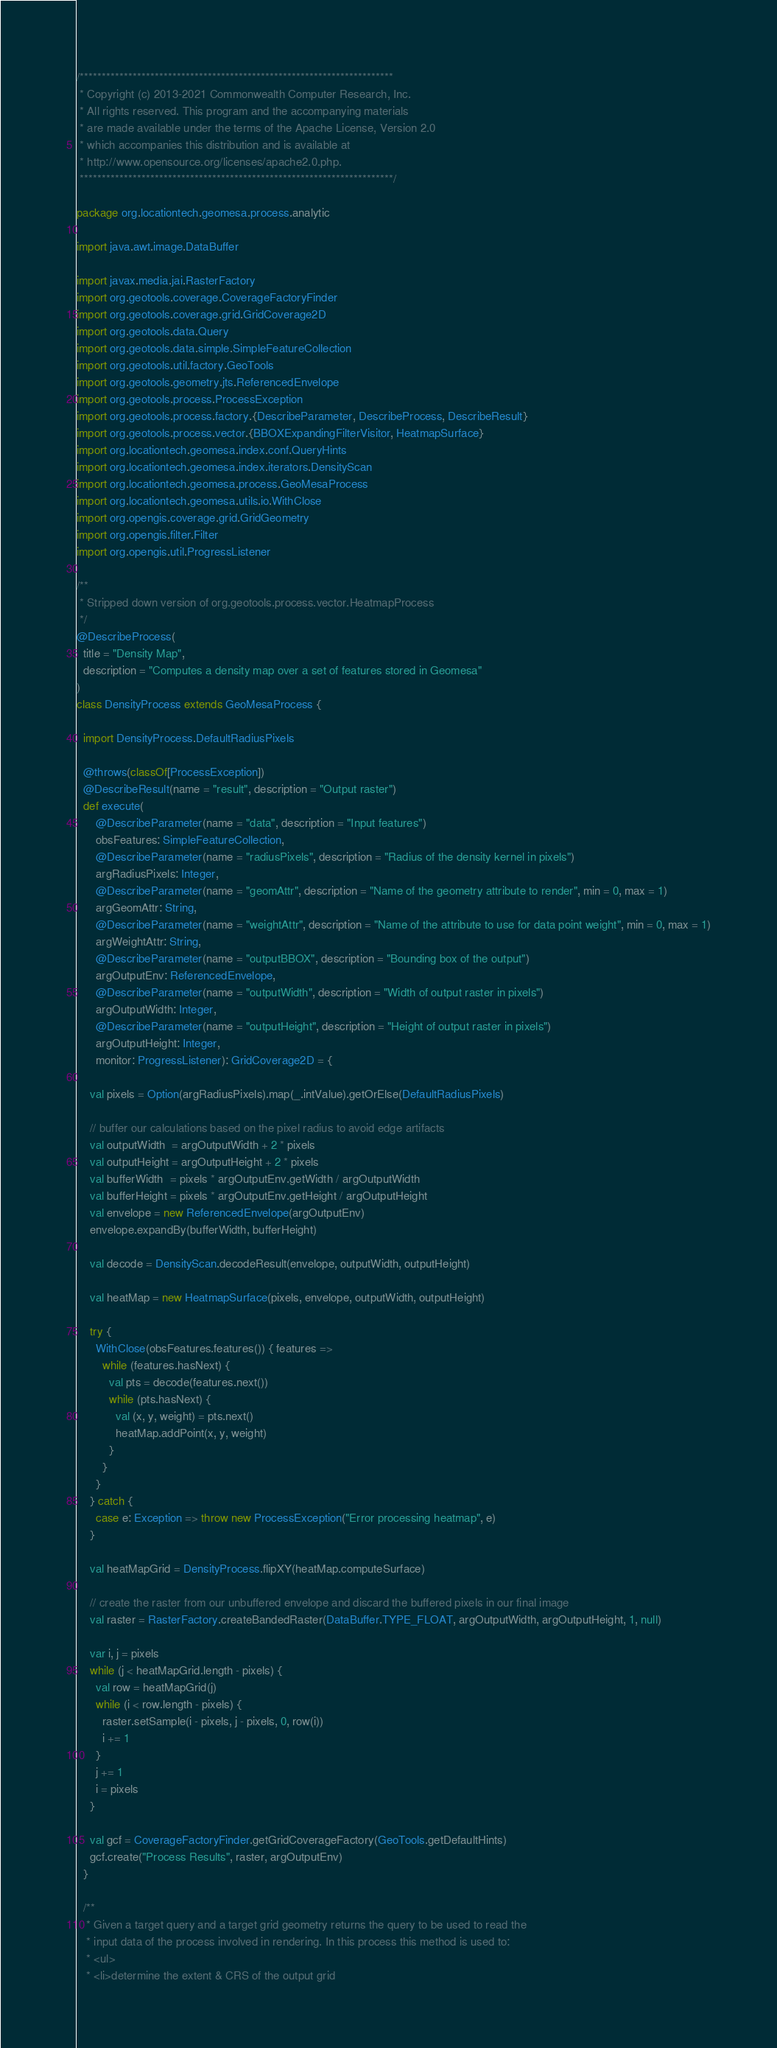<code> <loc_0><loc_0><loc_500><loc_500><_Scala_>/***********************************************************************
 * Copyright (c) 2013-2021 Commonwealth Computer Research, Inc.
 * All rights reserved. This program and the accompanying materials
 * are made available under the terms of the Apache License, Version 2.0
 * which accompanies this distribution and is available at
 * http://www.opensource.org/licenses/apache2.0.php.
 ***********************************************************************/

package org.locationtech.geomesa.process.analytic

import java.awt.image.DataBuffer

import javax.media.jai.RasterFactory
import org.geotools.coverage.CoverageFactoryFinder
import org.geotools.coverage.grid.GridCoverage2D
import org.geotools.data.Query
import org.geotools.data.simple.SimpleFeatureCollection
import org.geotools.util.factory.GeoTools
import org.geotools.geometry.jts.ReferencedEnvelope
import org.geotools.process.ProcessException
import org.geotools.process.factory.{DescribeParameter, DescribeProcess, DescribeResult}
import org.geotools.process.vector.{BBOXExpandingFilterVisitor, HeatmapSurface}
import org.locationtech.geomesa.index.conf.QueryHints
import org.locationtech.geomesa.index.iterators.DensityScan
import org.locationtech.geomesa.process.GeoMesaProcess
import org.locationtech.geomesa.utils.io.WithClose
import org.opengis.coverage.grid.GridGeometry
import org.opengis.filter.Filter
import org.opengis.util.ProgressListener

/**
 * Stripped down version of org.geotools.process.vector.HeatmapProcess
 */
@DescribeProcess(
  title = "Density Map",
  description = "Computes a density map over a set of features stored in Geomesa"
)
class DensityProcess extends GeoMesaProcess {

  import DensityProcess.DefaultRadiusPixels

  @throws(classOf[ProcessException])
  @DescribeResult(name = "result", description = "Output raster")
  def execute(
      @DescribeParameter(name = "data", description = "Input features")
      obsFeatures: SimpleFeatureCollection,
      @DescribeParameter(name = "radiusPixels", description = "Radius of the density kernel in pixels")
      argRadiusPixels: Integer,
      @DescribeParameter(name = "geomAttr", description = "Name of the geometry attribute to render", min = 0, max = 1)
      argGeomAttr: String,
      @DescribeParameter(name = "weightAttr", description = "Name of the attribute to use for data point weight", min = 0, max = 1)
      argWeightAttr: String,
      @DescribeParameter(name = "outputBBOX", description = "Bounding box of the output")
      argOutputEnv: ReferencedEnvelope,
      @DescribeParameter(name = "outputWidth", description = "Width of output raster in pixels")
      argOutputWidth: Integer,
      @DescribeParameter(name = "outputHeight", description = "Height of output raster in pixels")
      argOutputHeight: Integer,
      monitor: ProgressListener): GridCoverage2D = {

    val pixels = Option(argRadiusPixels).map(_.intValue).getOrElse(DefaultRadiusPixels)

    // buffer our calculations based on the pixel radius to avoid edge artifacts
    val outputWidth  = argOutputWidth + 2 * pixels
    val outputHeight = argOutputHeight + 2 * pixels
    val bufferWidth  = pixels * argOutputEnv.getWidth / argOutputWidth
    val bufferHeight = pixels * argOutputEnv.getHeight / argOutputHeight
    val envelope = new ReferencedEnvelope(argOutputEnv)
    envelope.expandBy(bufferWidth, bufferHeight)

    val decode = DensityScan.decodeResult(envelope, outputWidth, outputHeight)

    val heatMap = new HeatmapSurface(pixels, envelope, outputWidth, outputHeight)

    try {
      WithClose(obsFeatures.features()) { features =>
        while (features.hasNext) {
          val pts = decode(features.next())
          while (pts.hasNext) {
            val (x, y, weight) = pts.next()
            heatMap.addPoint(x, y, weight)
          }
        }
      }
    } catch {
      case e: Exception => throw new ProcessException("Error processing heatmap", e)
    }

    val heatMapGrid = DensityProcess.flipXY(heatMap.computeSurface)

    // create the raster from our unbuffered envelope and discard the buffered pixels in our final image
    val raster = RasterFactory.createBandedRaster(DataBuffer.TYPE_FLOAT, argOutputWidth, argOutputHeight, 1, null)

    var i, j = pixels
    while (j < heatMapGrid.length - pixels) {
      val row = heatMapGrid(j)
      while (i < row.length - pixels) {
        raster.setSample(i - pixels, j - pixels, 0, row(i))
        i += 1
      }
      j += 1
      i = pixels
    }

    val gcf = CoverageFactoryFinder.getGridCoverageFactory(GeoTools.getDefaultHints)
    gcf.create("Process Results", raster, argOutputEnv)
  }

  /**
   * Given a target query and a target grid geometry returns the query to be used to read the
   * input data of the process involved in rendering. In this process this method is used to:
   * <ul>
   * <li>determine the extent & CRS of the output grid</code> 